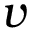Convert formula to latex. <formula><loc_0><loc_0><loc_500><loc_500>v</formula> 